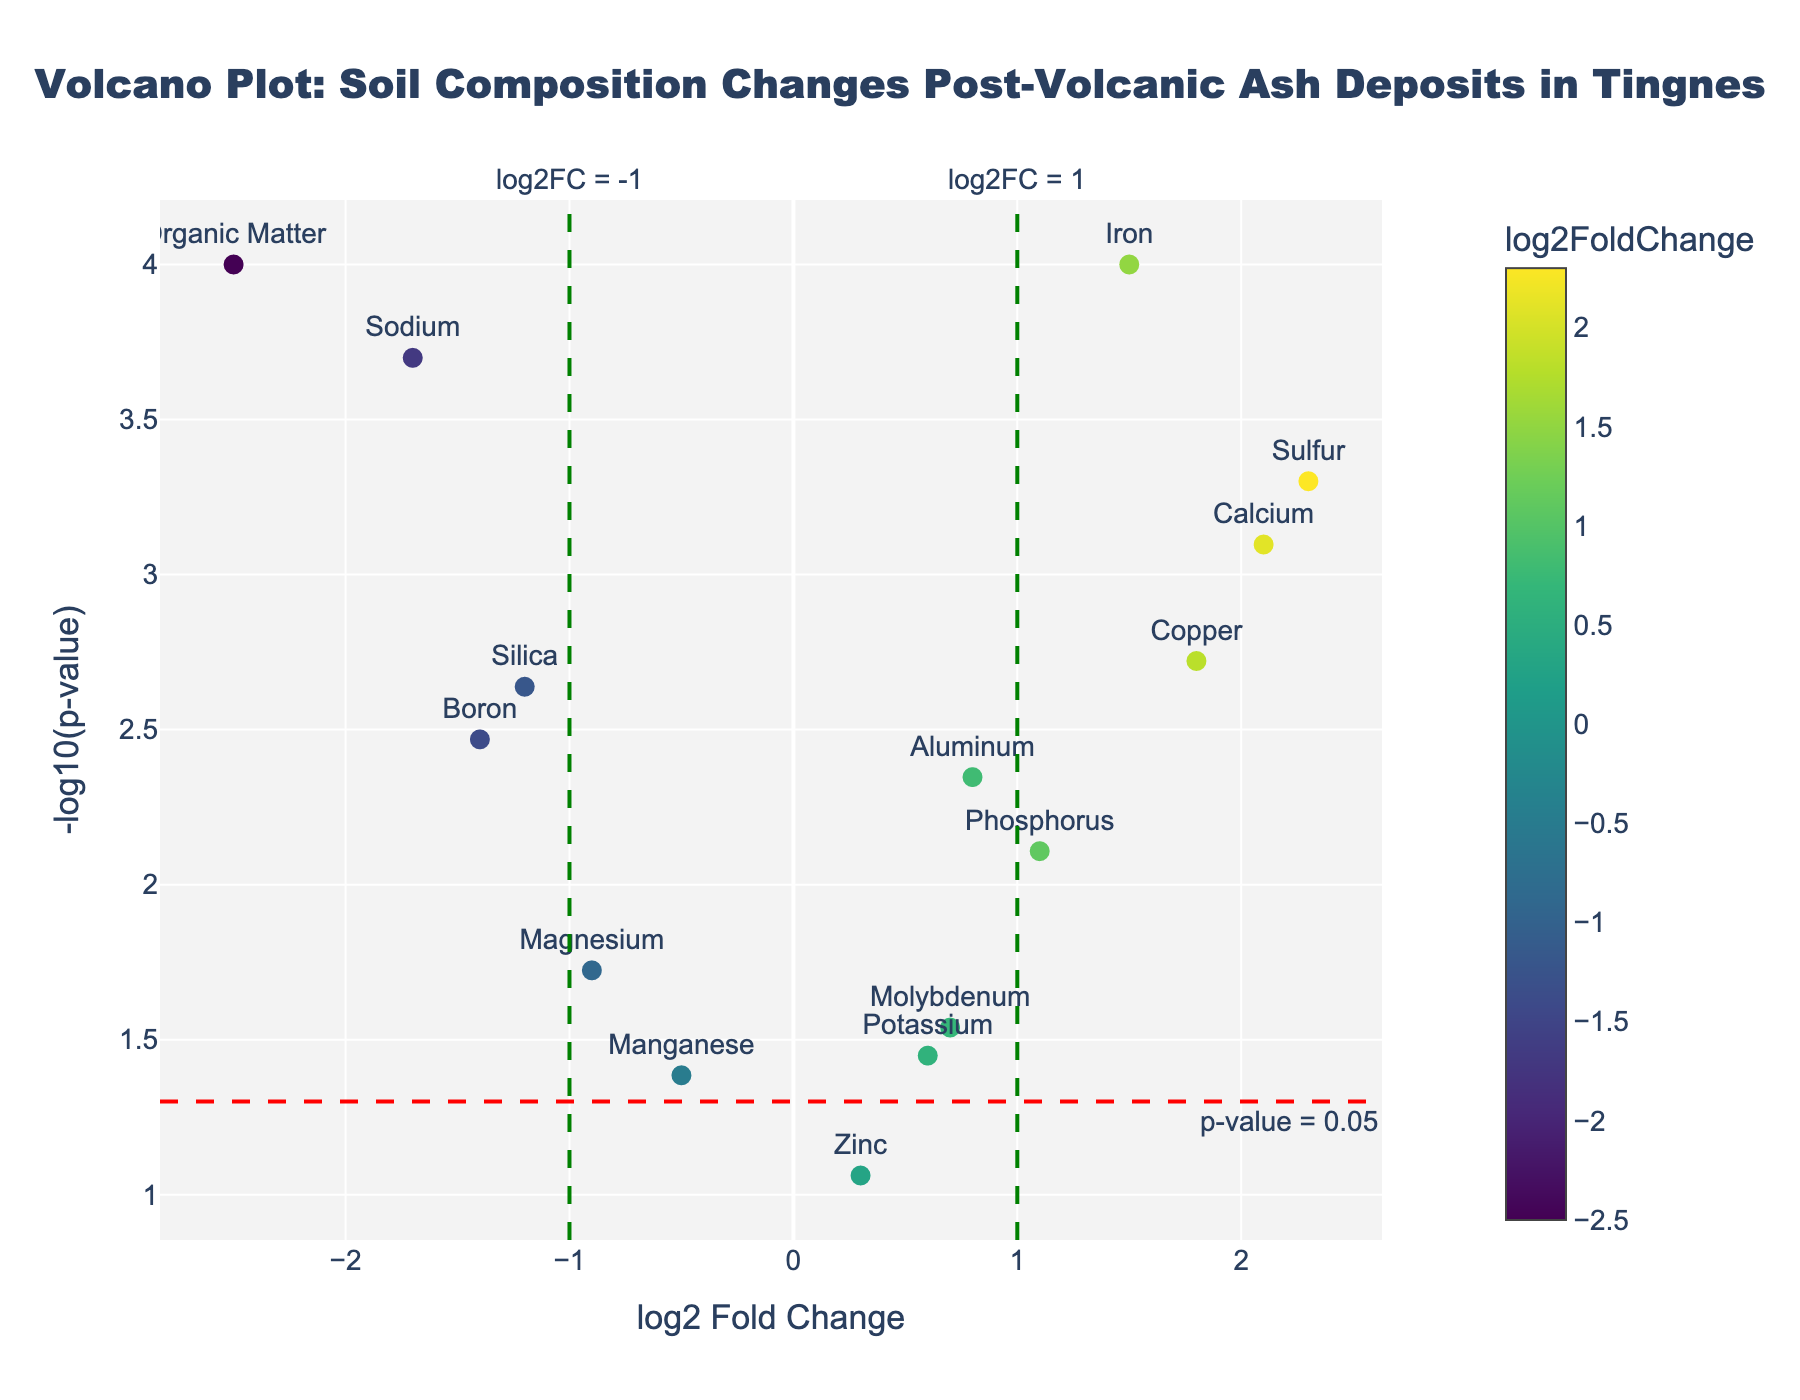What is the title of the plot? The title is displayed at the top center of the figure.
Answer: Volcano Plot: Soil Composition Changes Post-Volcanic Ash Deposits in Tingnes How many data points have p-values below 0.05? The horizontal red dashed line represents p-value = 0.05. Data points above this line have p-values below 0.05. There are 12 data points above this line.
Answer: 12 Which element shows the highest log2FoldChange and what is its value? By examining the x-axis, we can see that Sulfur is positioned furthest to the right indicating the highest log2FoldChange at 2.3.
Answer: Sulfur, 2.3 Are there more elements with a log2FoldChange above 0 or below 0? Count the number of elements on each side of the y-axis. There are 8 data points with log2FoldChange above 0 and 7 below 0.
Answer: Above 0 Which elements have significant changes (p-value < 0.05) and a positive log2FoldChange? Significant p-values are above the horizontal red dashed line, and positive log2FoldChange values are to the right of the y-axis. The elements are Aluminum, Iron, Calcium, Phosphorus, Sulfur, Copper, and Molybdenum.
Answer: Aluminum, Iron, Calcium, Phosphorus, Sulfur, Copper, Molybdenum What is the log2FoldChange range for Boron and Organic Matter? Find Boron and Organic Matter on the plot. Boron has a log2FoldChange of -1.4 and Organic Matter has -2.5. The range is the difference between these values. -1.4 - (-2.5) = 1.1.
Answer: 1.1 Which element has a significant change in composition and the lowest log2FoldChange? Significant changes are above the red dashed line, and the lowest log2FoldChange is the furthest to the left. Sodium has the lowest log2FoldChange at -1.7.
Answer: Sodium How does the p-value of Silica compare to that of Copper? Compare the height above the red dashed line for Silica and Copper. Silica's p-value places it slightly higher (-log10(p-value) closer to 3), while Copper is slightly lower, meaning Copper's p-value is smaller.
Answer: Silica's p-value is higher Which element has a p-value just above 0.05 and what is its log2FoldChange? Look for the element just above the red dashed line indicating p-value = 0.05. Manganese is just above this line with a log2FoldChange of -0.5.
Answer: Manganese, -0.5 What can you infer about the relationship between log2FoldChange and -log10(p-value) from this plot? Generally, higher absolute values of log2FoldChange tend to have higher values of -log10(p-value) indicating lower p-values, suggesting a significant change.
Answer: Larger changes in soil composition are more significant 